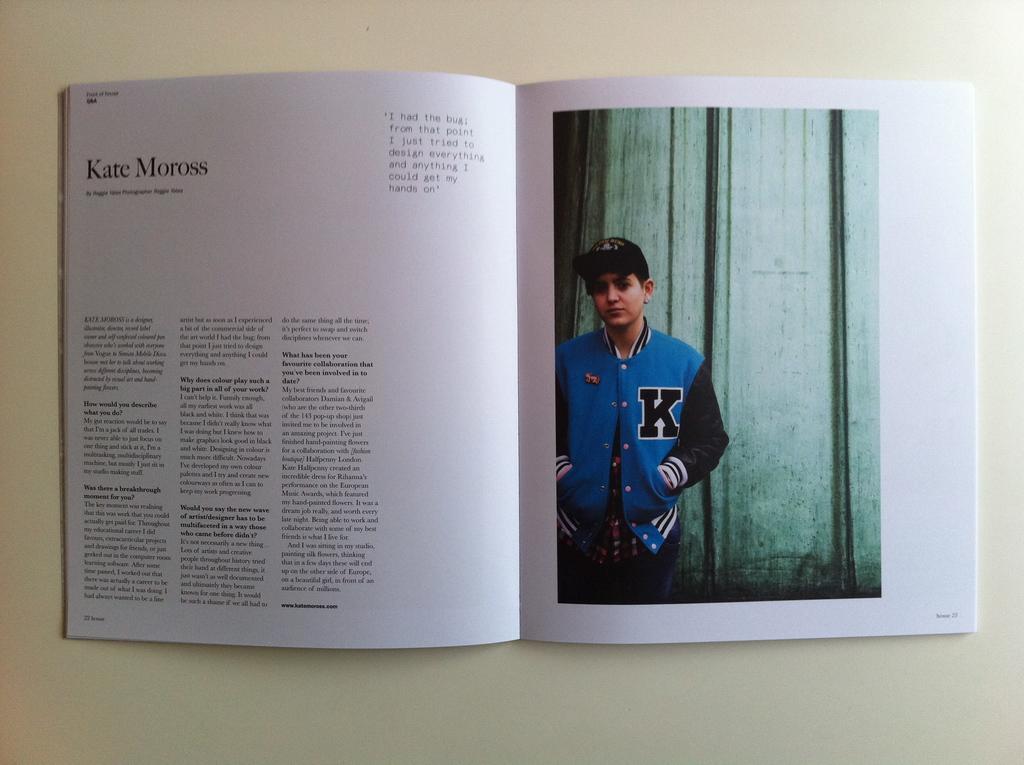What letter is on the boy's jacket?
Your answer should be very brief. K. What is the name on the left page?
Offer a very short reply. Kate moross. 